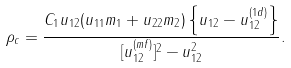<formula> <loc_0><loc_0><loc_500><loc_500>\rho _ { c } = \frac { C _ { 1 } u _ { 1 2 } ( u _ { 1 1 } m _ { 1 } + u _ { 2 2 } m _ { 2 } ) \left \{ u _ { 1 2 } - u _ { 1 2 } ^ { ( 1 d ) } \right \} } { [ u _ { 1 2 } ^ { ( m f ) } ] ^ { 2 } - u _ { 1 2 } ^ { 2 } } .</formula> 